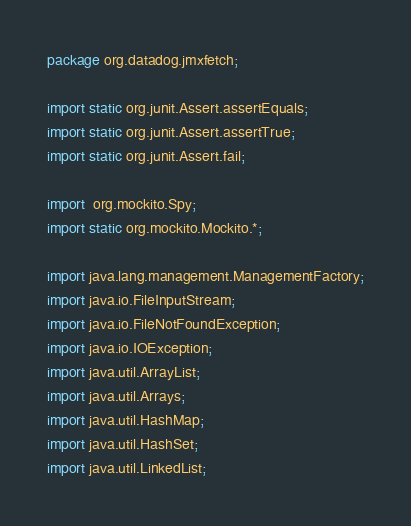Convert code to text. <code><loc_0><loc_0><loc_500><loc_500><_Java_>package org.datadog.jmxfetch;

import static org.junit.Assert.assertEquals;
import static org.junit.Assert.assertTrue;
import static org.junit.Assert.fail;

import  org.mockito.Spy;
import static org.mockito.Mockito.*;

import java.lang.management.ManagementFactory;
import java.io.FileInputStream;
import java.io.FileNotFoundException;
import java.io.IOException;
import java.util.ArrayList;
import java.util.Arrays;
import java.util.HashMap;
import java.util.HashSet;
import java.util.LinkedList;</code> 